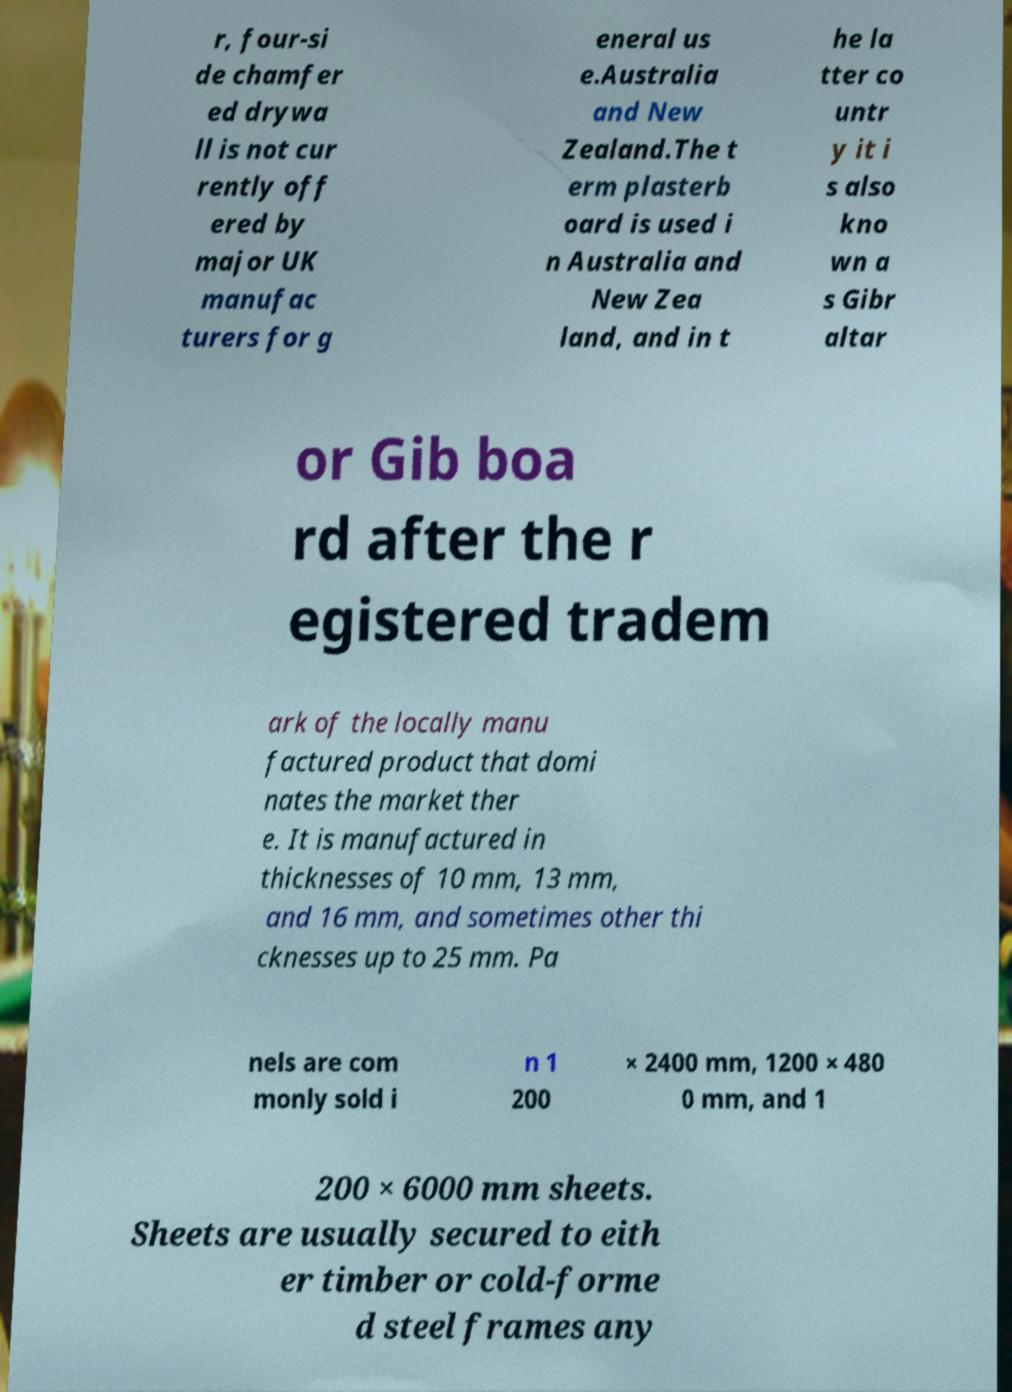I need the written content from this picture converted into text. Can you do that? r, four-si de chamfer ed drywa ll is not cur rently off ered by major UK manufac turers for g eneral us e.Australia and New Zealand.The t erm plasterb oard is used i n Australia and New Zea land, and in t he la tter co untr y it i s also kno wn a s Gibr altar or Gib boa rd after the r egistered tradem ark of the locally manu factured product that domi nates the market ther e. It is manufactured in thicknesses of 10 mm, 13 mm, and 16 mm, and sometimes other thi cknesses up to 25 mm. Pa nels are com monly sold i n 1 200 × 2400 mm, 1200 × 480 0 mm, and 1 200 × 6000 mm sheets. Sheets are usually secured to eith er timber or cold-forme d steel frames any 